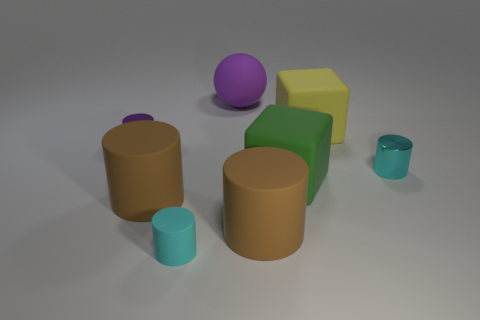Subtract all brown cylinders. How many cylinders are left? 3 Subtract all cyan cylinders. How many cylinders are left? 3 Subtract 1 cylinders. How many cylinders are left? 4 Subtract all purple cylinders. Subtract all yellow cubes. How many cylinders are left? 4 Add 2 brown rubber cylinders. How many objects exist? 10 Subtract all cylinders. How many objects are left? 3 Subtract all purple cylinders. How many yellow cubes are left? 1 Subtract all red rubber balls. Subtract all big matte cylinders. How many objects are left? 6 Add 6 tiny shiny objects. How many tiny shiny objects are left? 8 Add 1 purple matte spheres. How many purple matte spheres exist? 2 